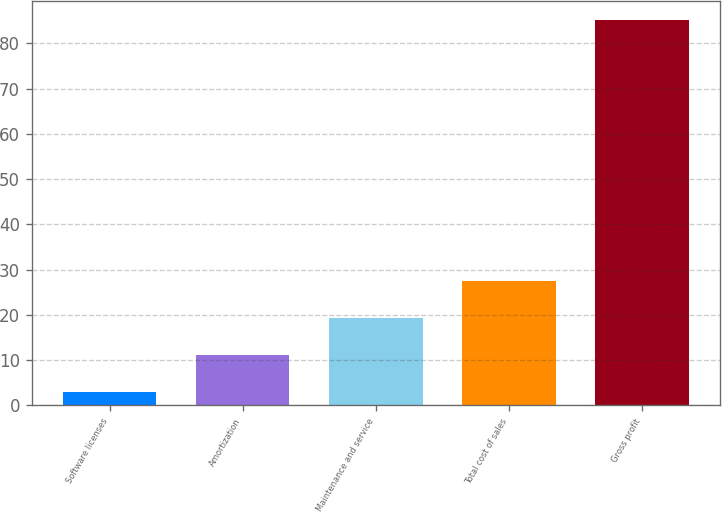Convert chart. <chart><loc_0><loc_0><loc_500><loc_500><bar_chart><fcel>Software licenses<fcel>Amortization<fcel>Maintenance and service<fcel>Total cost of sales<fcel>Gross profit<nl><fcel>2.9<fcel>11.12<fcel>19.34<fcel>27.56<fcel>85.1<nl></chart> 